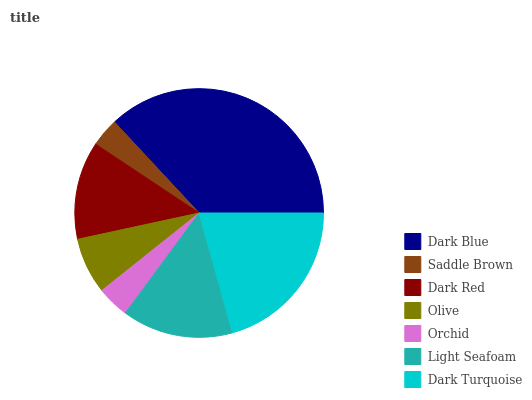Is Saddle Brown the minimum?
Answer yes or no. Yes. Is Dark Blue the maximum?
Answer yes or no. Yes. Is Dark Red the minimum?
Answer yes or no. No. Is Dark Red the maximum?
Answer yes or no. No. Is Dark Red greater than Saddle Brown?
Answer yes or no. Yes. Is Saddle Brown less than Dark Red?
Answer yes or no. Yes. Is Saddle Brown greater than Dark Red?
Answer yes or no. No. Is Dark Red less than Saddle Brown?
Answer yes or no. No. Is Dark Red the high median?
Answer yes or no. Yes. Is Dark Red the low median?
Answer yes or no. Yes. Is Dark Blue the high median?
Answer yes or no. No. Is Light Seafoam the low median?
Answer yes or no. No. 